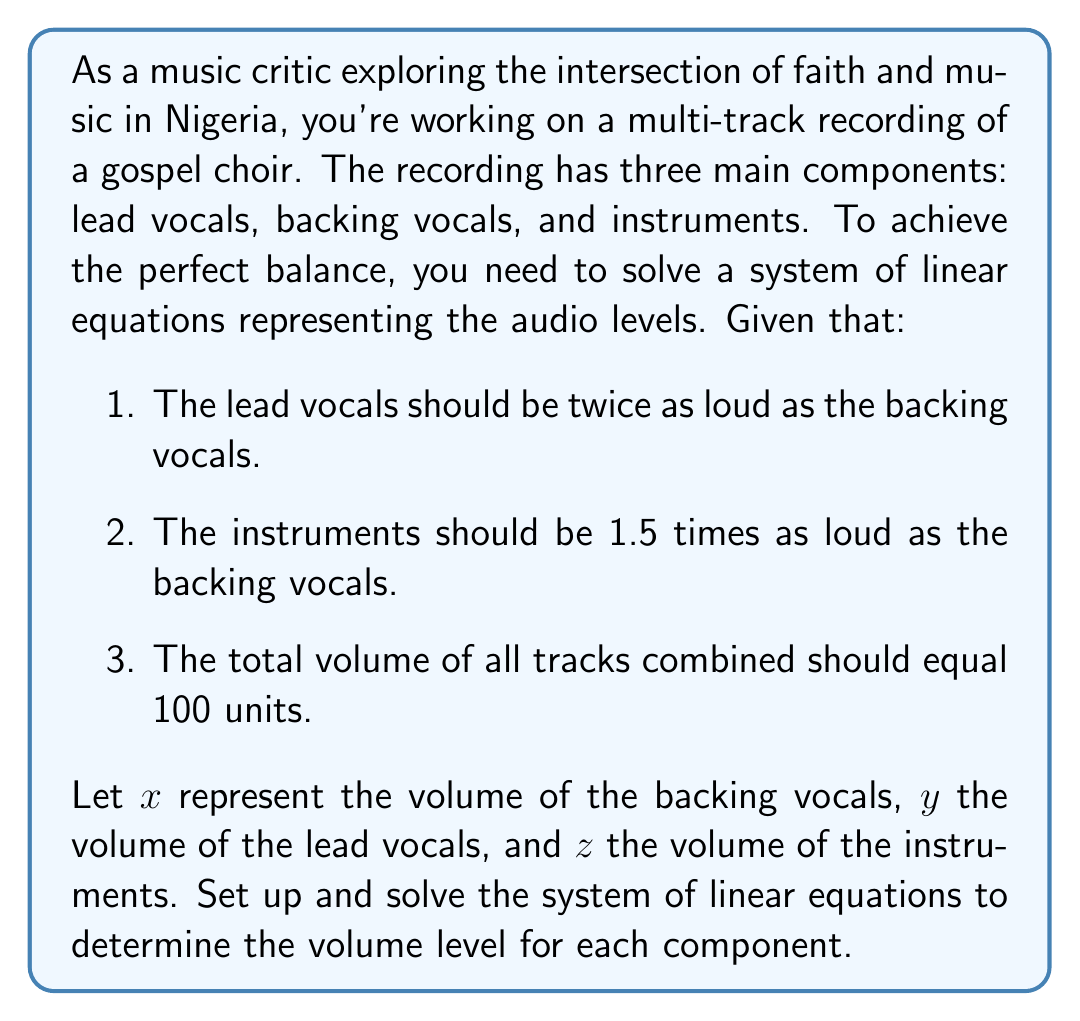Solve this math problem. Let's approach this step-by-step:

1) First, we'll set up our system of linear equations based on the given information:

   $$\begin{cases}
   y = 2x & \text{(lead vocals twice as loud as backing vocals)} \\
   z = 1.5x & \text{(instruments 1.5 times as loud as backing vocals)} \\
   x + y + z = 100 & \text{(total volume equals 100 units)}
   \end{cases}$$

2) We can substitute the expressions for $y$ and $z$ into the third equation:

   $$x + 2x + 1.5x = 100$$

3) Simplify the left side of the equation:

   $$4.5x = 100$$

4) Solve for $x$:

   $$x = \frac{100}{4.5} \approx 22.22$$

5) Now that we know $x$, we can solve for $y$ and $z$:

   $$y = 2x = 2(22.22) \approx 44.44$$
   $$z = 1.5x = 1.5(22.22) \approx 33.33$$

6) Let's verify that these values satisfy our original conditions:
   - Lead vocals ($y$) are twice as loud as backing vocals ($x$): $44.44 \approx 2(22.22)$
   - Instruments ($z$) are 1.5 times as loud as backing vocals ($x$): $33.33 \approx 1.5(22.22)$
   - Total volume: $22.22 + 44.44 + 33.33 \approx 100$

Thus, our solution satisfies all conditions.
Answer: The balanced audio levels for the multi-track recording are:
Backing vocals: $x \approx 22.22$ units
Lead vocals: $y \approx 44.44$ units
Instruments: $z \approx 33.33$ units 